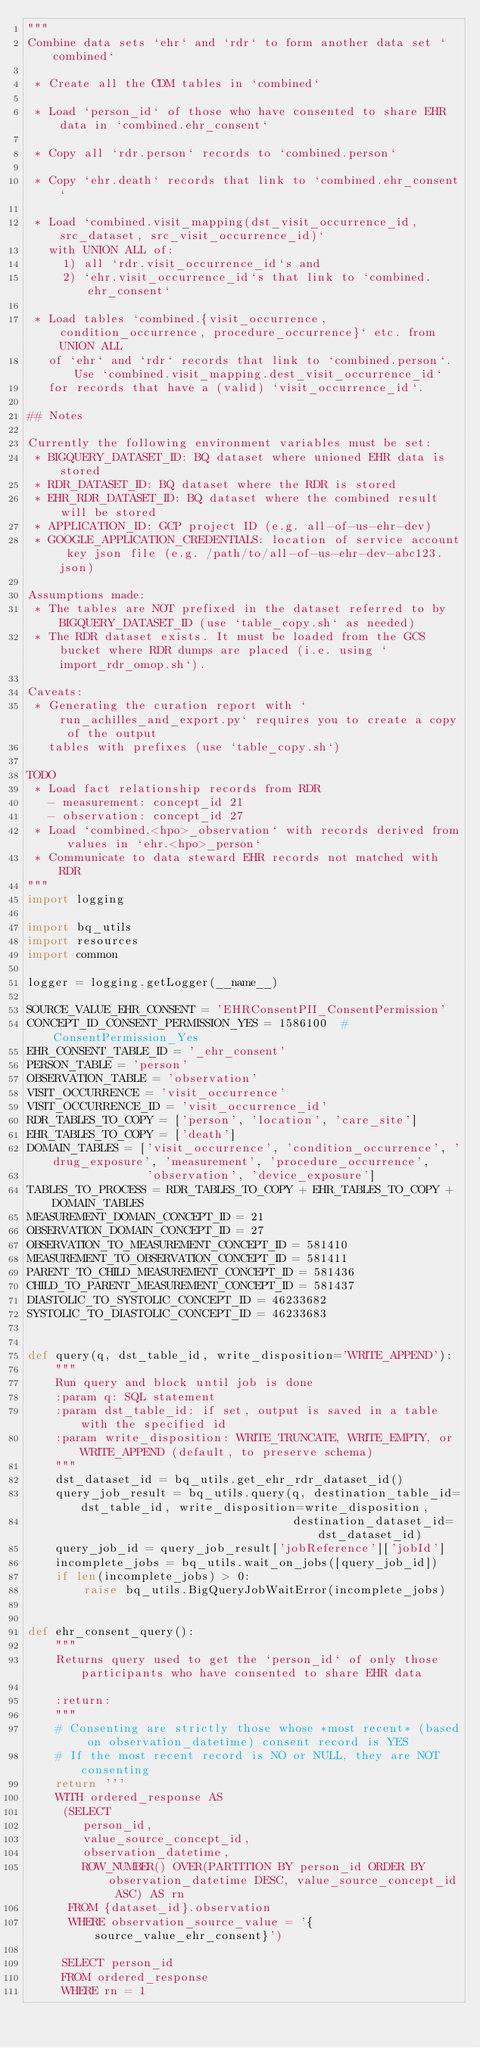Convert code to text. <code><loc_0><loc_0><loc_500><loc_500><_Python_>"""
Combine data sets `ehr` and `rdr` to form another data set `combined`

 * Create all the CDM tables in `combined`

 * Load `person_id` of those who have consented to share EHR data in `combined.ehr_consent`

 * Copy all `rdr.person` records to `combined.person`

 * Copy `ehr.death` records that link to `combined.ehr_consent`

 * Load `combined.visit_mapping(dst_visit_occurrence_id, src_dataset, src_visit_occurrence_id)`
   with UNION ALL of:
     1) all `rdr.visit_occurrence_id`s and
     2) `ehr.visit_occurrence_id`s that link to `combined.ehr_consent`

 * Load tables `combined.{visit_occurrence, condition_occurrence, procedure_occurrence}` etc. from UNION ALL
   of `ehr` and `rdr` records that link to `combined.person`. Use `combined.visit_mapping.dest_visit_occurrence_id`
   for records that have a (valid) `visit_occurrence_id`.

## Notes

Currently the following environment variables must be set:
 * BIGQUERY_DATASET_ID: BQ dataset where unioned EHR data is stored
 * RDR_DATASET_ID: BQ dataset where the RDR is stored
 * EHR_RDR_DATASET_ID: BQ dataset where the combined result will be stored
 * APPLICATION_ID: GCP project ID (e.g. all-of-us-ehr-dev)
 * GOOGLE_APPLICATION_CREDENTIALS: location of service account key json file (e.g. /path/to/all-of-us-ehr-dev-abc123.json)

Assumptions made:
 * The tables are NOT prefixed in the dataset referred to by BIGQUERY_DATASET_ID (use `table_copy.sh` as needed)
 * The RDR dataset exists. It must be loaded from the GCS bucket where RDR dumps are placed (i.e. using `import_rdr_omop.sh`).

Caveats:
 * Generating the curation report with `run_achilles_and_export.py` requires you to create a copy of the output
   tables with prefixes (use `table_copy.sh`)

TODO
 * Load fact relationship records from RDR
   - measurement: concept_id 21
   - observation: concept_id 27
 * Load `combined.<hpo>_observation` with records derived from values in `ehr.<hpo>_person`
 * Communicate to data steward EHR records not matched with RDR
"""
import logging

import bq_utils
import resources
import common

logger = logging.getLogger(__name__)

SOURCE_VALUE_EHR_CONSENT = 'EHRConsentPII_ConsentPermission'
CONCEPT_ID_CONSENT_PERMISSION_YES = 1586100  # ConsentPermission_Yes
EHR_CONSENT_TABLE_ID = '_ehr_consent'
PERSON_TABLE = 'person'
OBSERVATION_TABLE = 'observation'
VISIT_OCCURRENCE = 'visit_occurrence'
VISIT_OCCURRENCE_ID = 'visit_occurrence_id'
RDR_TABLES_TO_COPY = ['person', 'location', 'care_site']
EHR_TABLES_TO_COPY = ['death']
DOMAIN_TABLES = ['visit_occurrence', 'condition_occurrence', 'drug_exposure', 'measurement', 'procedure_occurrence',
                 'observation', 'device_exposure']
TABLES_TO_PROCESS = RDR_TABLES_TO_COPY + EHR_TABLES_TO_COPY + DOMAIN_TABLES
MEASUREMENT_DOMAIN_CONCEPT_ID = 21
OBSERVATION_DOMAIN_CONCEPT_ID = 27
OBSERVATION_TO_MEASUREMENT_CONCEPT_ID = 581410
MEASUREMENT_TO_OBSERVATION_CONCEPT_ID = 581411
PARENT_TO_CHILD_MEASUREMENT_CONCEPT_ID = 581436
CHILD_TO_PARENT_MEASUREMENT_CONCEPT_ID = 581437
DIASTOLIC_TO_SYSTOLIC_CONCEPT_ID = 46233682
SYSTOLIC_TO_DIASTOLIC_CONCEPT_ID = 46233683


def query(q, dst_table_id, write_disposition='WRITE_APPEND'):
    """
    Run query and block until job is done
    :param q: SQL statement
    :param dst_table_id: if set, output is saved in a table with the specified id
    :param write_disposition: WRITE_TRUNCATE, WRITE_EMPTY, or WRITE_APPEND (default, to preserve schema)
    """
    dst_dataset_id = bq_utils.get_ehr_rdr_dataset_id()
    query_job_result = bq_utils.query(q, destination_table_id=dst_table_id, write_disposition=write_disposition,
                                      destination_dataset_id=dst_dataset_id)
    query_job_id = query_job_result['jobReference']['jobId']
    incomplete_jobs = bq_utils.wait_on_jobs([query_job_id])
    if len(incomplete_jobs) > 0:
        raise bq_utils.BigQueryJobWaitError(incomplete_jobs)


def ehr_consent_query():
    """
    Returns query used to get the `person_id` of only those participants who have consented to share EHR data

    :return:
    """
    # Consenting are strictly those whose *most recent* (based on observation_datetime) consent record is YES
    # If the most recent record is NO or NULL, they are NOT consenting
    return '''
    WITH ordered_response AS
     (SELECT
        person_id, 
        value_source_concept_id,
        observation_datetime,
        ROW_NUMBER() OVER(PARTITION BY person_id ORDER BY observation_datetime DESC, value_source_concept_id ASC) AS rn
      FROM {dataset_id}.observation
      WHERE observation_source_value = '{source_value_ehr_consent}')
    
     SELECT person_id 
     FROM ordered_response
     WHERE rn = 1 </code> 